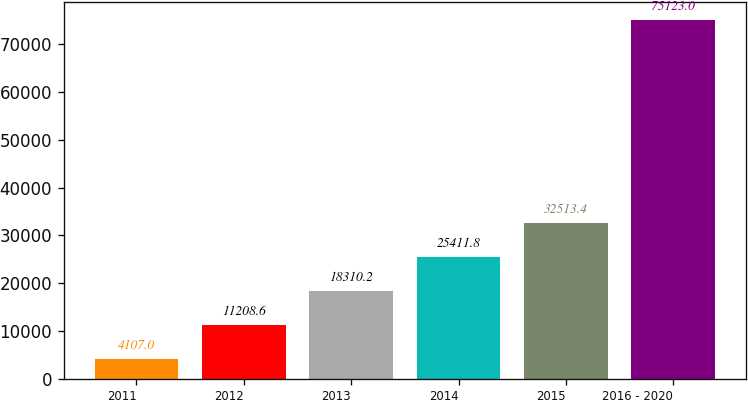<chart> <loc_0><loc_0><loc_500><loc_500><bar_chart><fcel>2011<fcel>2012<fcel>2013<fcel>2014<fcel>2015<fcel>2016 - 2020<nl><fcel>4107<fcel>11208.6<fcel>18310.2<fcel>25411.8<fcel>32513.4<fcel>75123<nl></chart> 